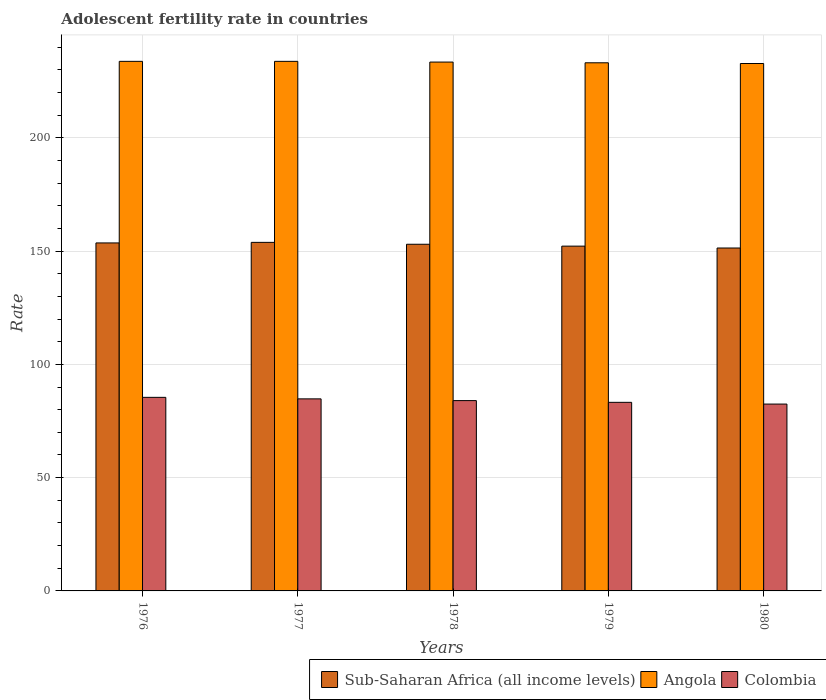How many groups of bars are there?
Give a very brief answer. 5. Are the number of bars per tick equal to the number of legend labels?
Provide a short and direct response. Yes. Are the number of bars on each tick of the X-axis equal?
Give a very brief answer. Yes. How many bars are there on the 4th tick from the left?
Ensure brevity in your answer.  3. What is the label of the 1st group of bars from the left?
Your answer should be compact. 1976. What is the adolescent fertility rate in Angola in 1978?
Your answer should be very brief. 233.41. Across all years, what is the maximum adolescent fertility rate in Colombia?
Keep it short and to the point. 85.43. Across all years, what is the minimum adolescent fertility rate in Colombia?
Provide a succinct answer. 82.47. In which year was the adolescent fertility rate in Angola maximum?
Your answer should be compact. 1976. In which year was the adolescent fertility rate in Colombia minimum?
Provide a short and direct response. 1980. What is the total adolescent fertility rate in Colombia in the graph?
Ensure brevity in your answer.  419.91. What is the difference between the adolescent fertility rate in Sub-Saharan Africa (all income levels) in 1976 and that in 1980?
Keep it short and to the point. 2.24. What is the difference between the adolescent fertility rate in Sub-Saharan Africa (all income levels) in 1978 and the adolescent fertility rate in Angola in 1980?
Ensure brevity in your answer.  -79.78. What is the average adolescent fertility rate in Angola per year?
Your answer should be compact. 233.35. In the year 1979, what is the difference between the adolescent fertility rate in Angola and adolescent fertility rate in Colombia?
Your response must be concise. 149.86. In how many years, is the adolescent fertility rate in Sub-Saharan Africa (all income levels) greater than 90?
Your answer should be very brief. 5. What is the ratio of the adolescent fertility rate in Sub-Saharan Africa (all income levels) in 1978 to that in 1980?
Keep it short and to the point. 1.01. What is the difference between the highest and the second highest adolescent fertility rate in Sub-Saharan Africa (all income levels)?
Ensure brevity in your answer.  0.25. What is the difference between the highest and the lowest adolescent fertility rate in Angola?
Make the answer very short. 0.95. In how many years, is the adolescent fertility rate in Colombia greater than the average adolescent fertility rate in Colombia taken over all years?
Provide a short and direct response. 3. What does the 2nd bar from the left in 1978 represents?
Offer a very short reply. Angola. What does the 3rd bar from the right in 1980 represents?
Offer a very short reply. Sub-Saharan Africa (all income levels). Is it the case that in every year, the sum of the adolescent fertility rate in Angola and adolescent fertility rate in Sub-Saharan Africa (all income levels) is greater than the adolescent fertility rate in Colombia?
Give a very brief answer. Yes. How many years are there in the graph?
Offer a very short reply. 5. Are the values on the major ticks of Y-axis written in scientific E-notation?
Keep it short and to the point. No. Does the graph contain grids?
Your answer should be very brief. Yes. How are the legend labels stacked?
Offer a very short reply. Horizontal. What is the title of the graph?
Keep it short and to the point. Adolescent fertility rate in countries. Does "Europe(developing only)" appear as one of the legend labels in the graph?
Offer a terse response. No. What is the label or title of the Y-axis?
Ensure brevity in your answer.  Rate. What is the Rate in Sub-Saharan Africa (all income levels) in 1976?
Ensure brevity in your answer.  153.59. What is the Rate in Angola in 1976?
Offer a terse response. 233.73. What is the Rate in Colombia in 1976?
Your response must be concise. 85.43. What is the Rate of Sub-Saharan Africa (all income levels) in 1977?
Provide a succinct answer. 153.84. What is the Rate in Angola in 1977?
Make the answer very short. 233.73. What is the Rate in Colombia in 1977?
Your answer should be compact. 84.77. What is the Rate of Sub-Saharan Africa (all income levels) in 1978?
Your answer should be compact. 153. What is the Rate of Angola in 1978?
Your answer should be very brief. 233.41. What is the Rate in Colombia in 1978?
Offer a very short reply. 84. What is the Rate of Sub-Saharan Africa (all income levels) in 1979?
Offer a terse response. 152.17. What is the Rate in Angola in 1979?
Provide a short and direct response. 233.09. What is the Rate in Colombia in 1979?
Your response must be concise. 83.24. What is the Rate in Sub-Saharan Africa (all income levels) in 1980?
Give a very brief answer. 151.35. What is the Rate of Angola in 1980?
Provide a succinct answer. 232.78. What is the Rate in Colombia in 1980?
Your response must be concise. 82.47. Across all years, what is the maximum Rate of Sub-Saharan Africa (all income levels)?
Offer a very short reply. 153.84. Across all years, what is the maximum Rate in Angola?
Make the answer very short. 233.73. Across all years, what is the maximum Rate of Colombia?
Ensure brevity in your answer.  85.43. Across all years, what is the minimum Rate of Sub-Saharan Africa (all income levels)?
Give a very brief answer. 151.35. Across all years, what is the minimum Rate in Angola?
Offer a terse response. 232.78. Across all years, what is the minimum Rate of Colombia?
Your response must be concise. 82.47. What is the total Rate of Sub-Saharan Africa (all income levels) in the graph?
Ensure brevity in your answer.  763.95. What is the total Rate in Angola in the graph?
Your answer should be compact. 1166.74. What is the total Rate in Colombia in the graph?
Make the answer very short. 419.91. What is the difference between the Rate of Sub-Saharan Africa (all income levels) in 1976 and that in 1977?
Ensure brevity in your answer.  -0.25. What is the difference between the Rate in Angola in 1976 and that in 1977?
Give a very brief answer. 0. What is the difference between the Rate of Colombia in 1976 and that in 1977?
Your response must be concise. 0.67. What is the difference between the Rate in Sub-Saharan Africa (all income levels) in 1976 and that in 1978?
Give a very brief answer. 0.59. What is the difference between the Rate in Angola in 1976 and that in 1978?
Provide a short and direct response. 0.32. What is the difference between the Rate of Colombia in 1976 and that in 1978?
Ensure brevity in your answer.  1.43. What is the difference between the Rate in Sub-Saharan Africa (all income levels) in 1976 and that in 1979?
Your answer should be very brief. 1.42. What is the difference between the Rate in Angola in 1976 and that in 1979?
Make the answer very short. 0.64. What is the difference between the Rate in Colombia in 1976 and that in 1979?
Your response must be concise. 2.2. What is the difference between the Rate of Sub-Saharan Africa (all income levels) in 1976 and that in 1980?
Offer a terse response. 2.24. What is the difference between the Rate of Angola in 1976 and that in 1980?
Your response must be concise. 0.95. What is the difference between the Rate in Colombia in 1976 and that in 1980?
Your answer should be very brief. 2.96. What is the difference between the Rate in Sub-Saharan Africa (all income levels) in 1977 and that in 1978?
Your answer should be compact. 0.84. What is the difference between the Rate of Angola in 1977 and that in 1978?
Provide a succinct answer. 0.32. What is the difference between the Rate of Colombia in 1977 and that in 1978?
Offer a terse response. 0.77. What is the difference between the Rate of Sub-Saharan Africa (all income levels) in 1977 and that in 1979?
Ensure brevity in your answer.  1.66. What is the difference between the Rate in Angola in 1977 and that in 1979?
Provide a succinct answer. 0.64. What is the difference between the Rate in Colombia in 1977 and that in 1979?
Keep it short and to the point. 1.53. What is the difference between the Rate in Sub-Saharan Africa (all income levels) in 1977 and that in 1980?
Ensure brevity in your answer.  2.49. What is the difference between the Rate of Angola in 1977 and that in 1980?
Offer a very short reply. 0.95. What is the difference between the Rate of Colombia in 1977 and that in 1980?
Your answer should be compact. 2.3. What is the difference between the Rate in Sub-Saharan Africa (all income levels) in 1978 and that in 1979?
Offer a very short reply. 0.83. What is the difference between the Rate in Angola in 1978 and that in 1979?
Offer a very short reply. 0.32. What is the difference between the Rate of Colombia in 1978 and that in 1979?
Your answer should be compact. 0.77. What is the difference between the Rate in Sub-Saharan Africa (all income levels) in 1978 and that in 1980?
Make the answer very short. 1.65. What is the difference between the Rate in Angola in 1978 and that in 1980?
Keep it short and to the point. 0.64. What is the difference between the Rate in Colombia in 1978 and that in 1980?
Provide a short and direct response. 1.53. What is the difference between the Rate in Sub-Saharan Africa (all income levels) in 1979 and that in 1980?
Ensure brevity in your answer.  0.82. What is the difference between the Rate in Angola in 1979 and that in 1980?
Your answer should be compact. 0.32. What is the difference between the Rate in Colombia in 1979 and that in 1980?
Provide a succinct answer. 0.77. What is the difference between the Rate of Sub-Saharan Africa (all income levels) in 1976 and the Rate of Angola in 1977?
Keep it short and to the point. -80.14. What is the difference between the Rate of Sub-Saharan Africa (all income levels) in 1976 and the Rate of Colombia in 1977?
Ensure brevity in your answer.  68.82. What is the difference between the Rate of Angola in 1976 and the Rate of Colombia in 1977?
Offer a very short reply. 148.96. What is the difference between the Rate of Sub-Saharan Africa (all income levels) in 1976 and the Rate of Angola in 1978?
Ensure brevity in your answer.  -79.82. What is the difference between the Rate in Sub-Saharan Africa (all income levels) in 1976 and the Rate in Colombia in 1978?
Your answer should be compact. 69.59. What is the difference between the Rate in Angola in 1976 and the Rate in Colombia in 1978?
Give a very brief answer. 149.73. What is the difference between the Rate in Sub-Saharan Africa (all income levels) in 1976 and the Rate in Angola in 1979?
Your answer should be very brief. -79.5. What is the difference between the Rate in Sub-Saharan Africa (all income levels) in 1976 and the Rate in Colombia in 1979?
Provide a succinct answer. 70.35. What is the difference between the Rate of Angola in 1976 and the Rate of Colombia in 1979?
Offer a very short reply. 150.49. What is the difference between the Rate of Sub-Saharan Africa (all income levels) in 1976 and the Rate of Angola in 1980?
Keep it short and to the point. -79.19. What is the difference between the Rate in Sub-Saharan Africa (all income levels) in 1976 and the Rate in Colombia in 1980?
Offer a terse response. 71.12. What is the difference between the Rate of Angola in 1976 and the Rate of Colombia in 1980?
Ensure brevity in your answer.  151.26. What is the difference between the Rate of Sub-Saharan Africa (all income levels) in 1977 and the Rate of Angola in 1978?
Keep it short and to the point. -79.57. What is the difference between the Rate in Sub-Saharan Africa (all income levels) in 1977 and the Rate in Colombia in 1978?
Provide a succinct answer. 69.84. What is the difference between the Rate in Angola in 1977 and the Rate in Colombia in 1978?
Provide a succinct answer. 149.73. What is the difference between the Rate of Sub-Saharan Africa (all income levels) in 1977 and the Rate of Angola in 1979?
Provide a succinct answer. -79.26. What is the difference between the Rate of Sub-Saharan Africa (all income levels) in 1977 and the Rate of Colombia in 1979?
Offer a terse response. 70.6. What is the difference between the Rate in Angola in 1977 and the Rate in Colombia in 1979?
Give a very brief answer. 150.49. What is the difference between the Rate of Sub-Saharan Africa (all income levels) in 1977 and the Rate of Angola in 1980?
Provide a succinct answer. -78.94. What is the difference between the Rate of Sub-Saharan Africa (all income levels) in 1977 and the Rate of Colombia in 1980?
Provide a succinct answer. 71.37. What is the difference between the Rate of Angola in 1977 and the Rate of Colombia in 1980?
Give a very brief answer. 151.26. What is the difference between the Rate of Sub-Saharan Africa (all income levels) in 1978 and the Rate of Angola in 1979?
Provide a succinct answer. -80.09. What is the difference between the Rate in Sub-Saharan Africa (all income levels) in 1978 and the Rate in Colombia in 1979?
Provide a short and direct response. 69.76. What is the difference between the Rate in Angola in 1978 and the Rate in Colombia in 1979?
Provide a succinct answer. 150.18. What is the difference between the Rate in Sub-Saharan Africa (all income levels) in 1978 and the Rate in Angola in 1980?
Keep it short and to the point. -79.78. What is the difference between the Rate of Sub-Saharan Africa (all income levels) in 1978 and the Rate of Colombia in 1980?
Keep it short and to the point. 70.53. What is the difference between the Rate of Angola in 1978 and the Rate of Colombia in 1980?
Your answer should be very brief. 150.94. What is the difference between the Rate of Sub-Saharan Africa (all income levels) in 1979 and the Rate of Angola in 1980?
Give a very brief answer. -80.6. What is the difference between the Rate in Sub-Saharan Africa (all income levels) in 1979 and the Rate in Colombia in 1980?
Provide a short and direct response. 69.7. What is the difference between the Rate of Angola in 1979 and the Rate of Colombia in 1980?
Your answer should be compact. 150.62. What is the average Rate of Sub-Saharan Africa (all income levels) per year?
Offer a terse response. 152.79. What is the average Rate in Angola per year?
Your answer should be compact. 233.35. What is the average Rate of Colombia per year?
Provide a succinct answer. 83.98. In the year 1976, what is the difference between the Rate in Sub-Saharan Africa (all income levels) and Rate in Angola?
Keep it short and to the point. -80.14. In the year 1976, what is the difference between the Rate in Sub-Saharan Africa (all income levels) and Rate in Colombia?
Give a very brief answer. 68.16. In the year 1976, what is the difference between the Rate of Angola and Rate of Colombia?
Make the answer very short. 148.3. In the year 1977, what is the difference between the Rate in Sub-Saharan Africa (all income levels) and Rate in Angola?
Your answer should be very brief. -79.89. In the year 1977, what is the difference between the Rate of Sub-Saharan Africa (all income levels) and Rate of Colombia?
Offer a terse response. 69.07. In the year 1977, what is the difference between the Rate of Angola and Rate of Colombia?
Make the answer very short. 148.96. In the year 1978, what is the difference between the Rate in Sub-Saharan Africa (all income levels) and Rate in Angola?
Ensure brevity in your answer.  -80.41. In the year 1978, what is the difference between the Rate of Sub-Saharan Africa (all income levels) and Rate of Colombia?
Give a very brief answer. 69. In the year 1978, what is the difference between the Rate of Angola and Rate of Colombia?
Your answer should be compact. 149.41. In the year 1979, what is the difference between the Rate of Sub-Saharan Africa (all income levels) and Rate of Angola?
Keep it short and to the point. -80.92. In the year 1979, what is the difference between the Rate in Sub-Saharan Africa (all income levels) and Rate in Colombia?
Offer a terse response. 68.94. In the year 1979, what is the difference between the Rate of Angola and Rate of Colombia?
Keep it short and to the point. 149.86. In the year 1980, what is the difference between the Rate of Sub-Saharan Africa (all income levels) and Rate of Angola?
Offer a terse response. -81.43. In the year 1980, what is the difference between the Rate in Sub-Saharan Africa (all income levels) and Rate in Colombia?
Ensure brevity in your answer.  68.88. In the year 1980, what is the difference between the Rate in Angola and Rate in Colombia?
Give a very brief answer. 150.31. What is the ratio of the Rate in Angola in 1976 to that in 1977?
Give a very brief answer. 1. What is the ratio of the Rate in Colombia in 1976 to that in 1977?
Give a very brief answer. 1.01. What is the ratio of the Rate in Sub-Saharan Africa (all income levels) in 1976 to that in 1978?
Keep it short and to the point. 1. What is the ratio of the Rate in Colombia in 1976 to that in 1978?
Keep it short and to the point. 1.02. What is the ratio of the Rate in Sub-Saharan Africa (all income levels) in 1976 to that in 1979?
Give a very brief answer. 1.01. What is the ratio of the Rate of Angola in 1976 to that in 1979?
Provide a succinct answer. 1. What is the ratio of the Rate of Colombia in 1976 to that in 1979?
Provide a succinct answer. 1.03. What is the ratio of the Rate in Sub-Saharan Africa (all income levels) in 1976 to that in 1980?
Offer a terse response. 1.01. What is the ratio of the Rate of Colombia in 1976 to that in 1980?
Your response must be concise. 1.04. What is the ratio of the Rate in Colombia in 1977 to that in 1978?
Provide a short and direct response. 1.01. What is the ratio of the Rate in Sub-Saharan Africa (all income levels) in 1977 to that in 1979?
Your answer should be compact. 1.01. What is the ratio of the Rate of Angola in 1977 to that in 1979?
Your response must be concise. 1. What is the ratio of the Rate of Colombia in 1977 to that in 1979?
Offer a very short reply. 1.02. What is the ratio of the Rate in Sub-Saharan Africa (all income levels) in 1977 to that in 1980?
Ensure brevity in your answer.  1.02. What is the ratio of the Rate of Angola in 1977 to that in 1980?
Make the answer very short. 1. What is the ratio of the Rate of Colombia in 1977 to that in 1980?
Provide a short and direct response. 1.03. What is the ratio of the Rate of Sub-Saharan Africa (all income levels) in 1978 to that in 1979?
Offer a very short reply. 1.01. What is the ratio of the Rate of Colombia in 1978 to that in 1979?
Make the answer very short. 1.01. What is the ratio of the Rate of Sub-Saharan Africa (all income levels) in 1978 to that in 1980?
Provide a succinct answer. 1.01. What is the ratio of the Rate of Angola in 1978 to that in 1980?
Your answer should be compact. 1. What is the ratio of the Rate in Colombia in 1978 to that in 1980?
Ensure brevity in your answer.  1.02. What is the ratio of the Rate in Sub-Saharan Africa (all income levels) in 1979 to that in 1980?
Ensure brevity in your answer.  1.01. What is the ratio of the Rate of Angola in 1979 to that in 1980?
Your response must be concise. 1. What is the ratio of the Rate of Colombia in 1979 to that in 1980?
Provide a succinct answer. 1.01. What is the difference between the highest and the second highest Rate of Sub-Saharan Africa (all income levels)?
Give a very brief answer. 0.25. What is the difference between the highest and the second highest Rate of Angola?
Offer a terse response. 0. What is the difference between the highest and the second highest Rate of Colombia?
Offer a very short reply. 0.67. What is the difference between the highest and the lowest Rate of Sub-Saharan Africa (all income levels)?
Offer a terse response. 2.49. What is the difference between the highest and the lowest Rate of Angola?
Your answer should be very brief. 0.95. What is the difference between the highest and the lowest Rate in Colombia?
Make the answer very short. 2.96. 